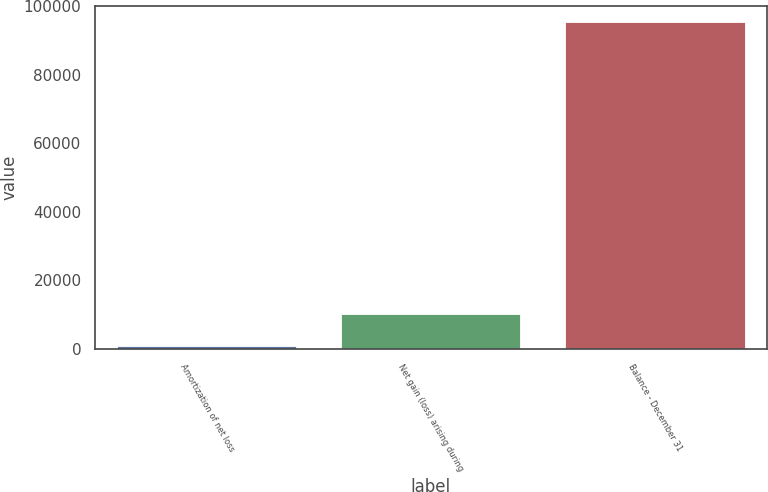Convert chart. <chart><loc_0><loc_0><loc_500><loc_500><bar_chart><fcel>Amortization of net loss<fcel>Net gain (loss) arising during<fcel>Balance - December 31<nl><fcel>791<fcel>10237.7<fcel>95258<nl></chart> 